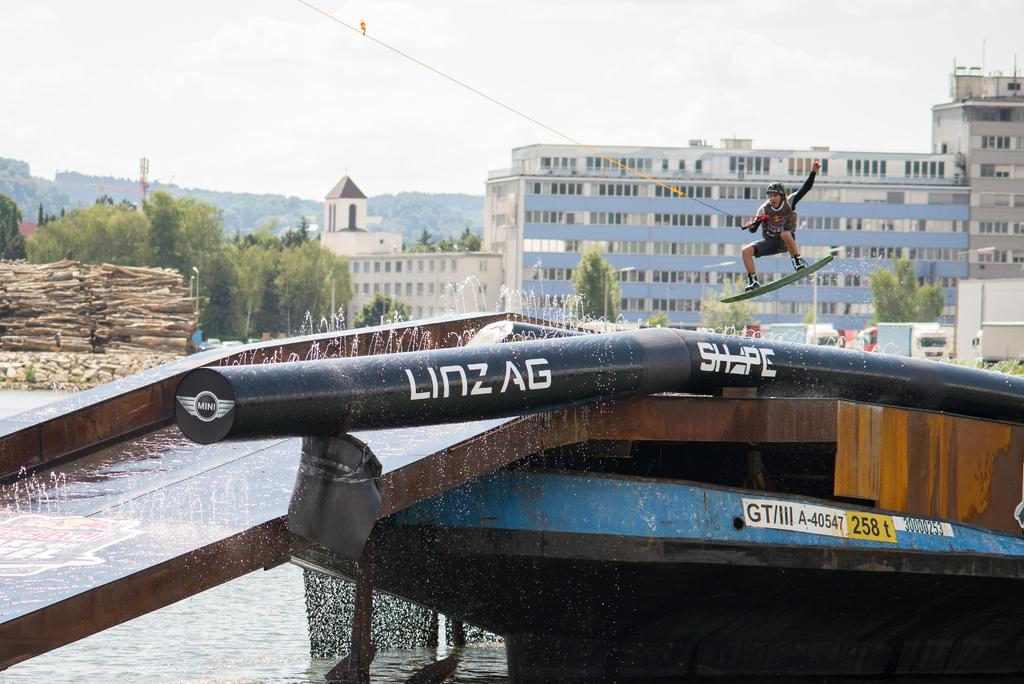<image>
Render a clear and concise summary of the photo. the word Linzag that is on the boat 